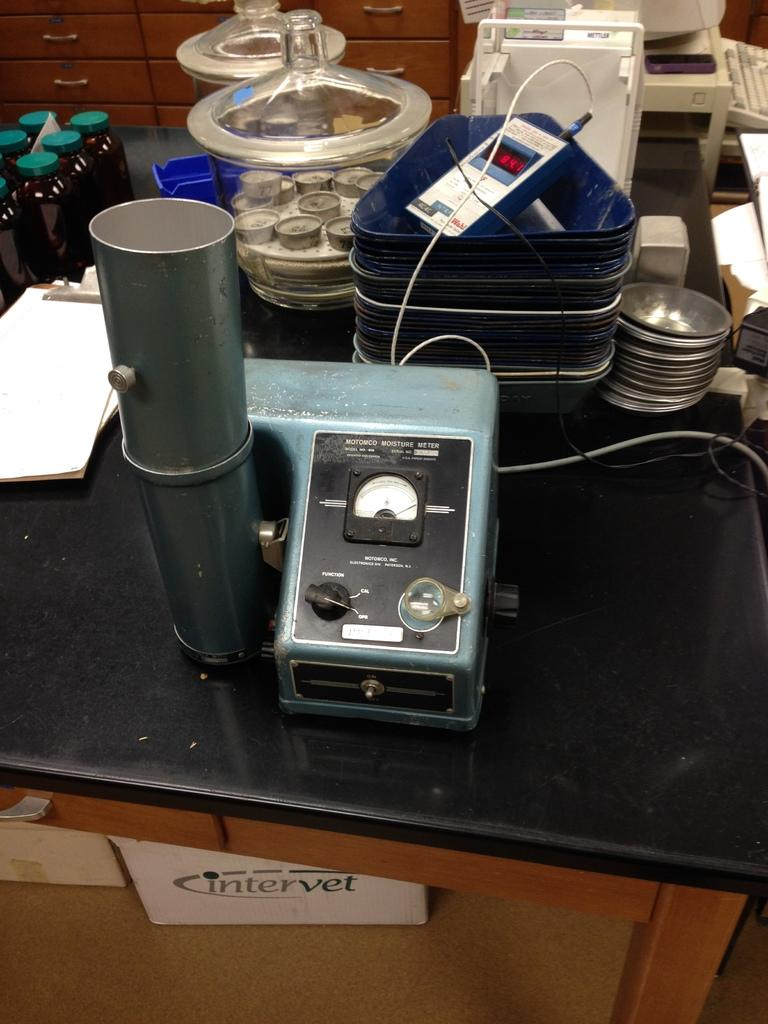<image>
Summarize the visual content of the image. a white box underneath a desk that says 'intervet' on it 